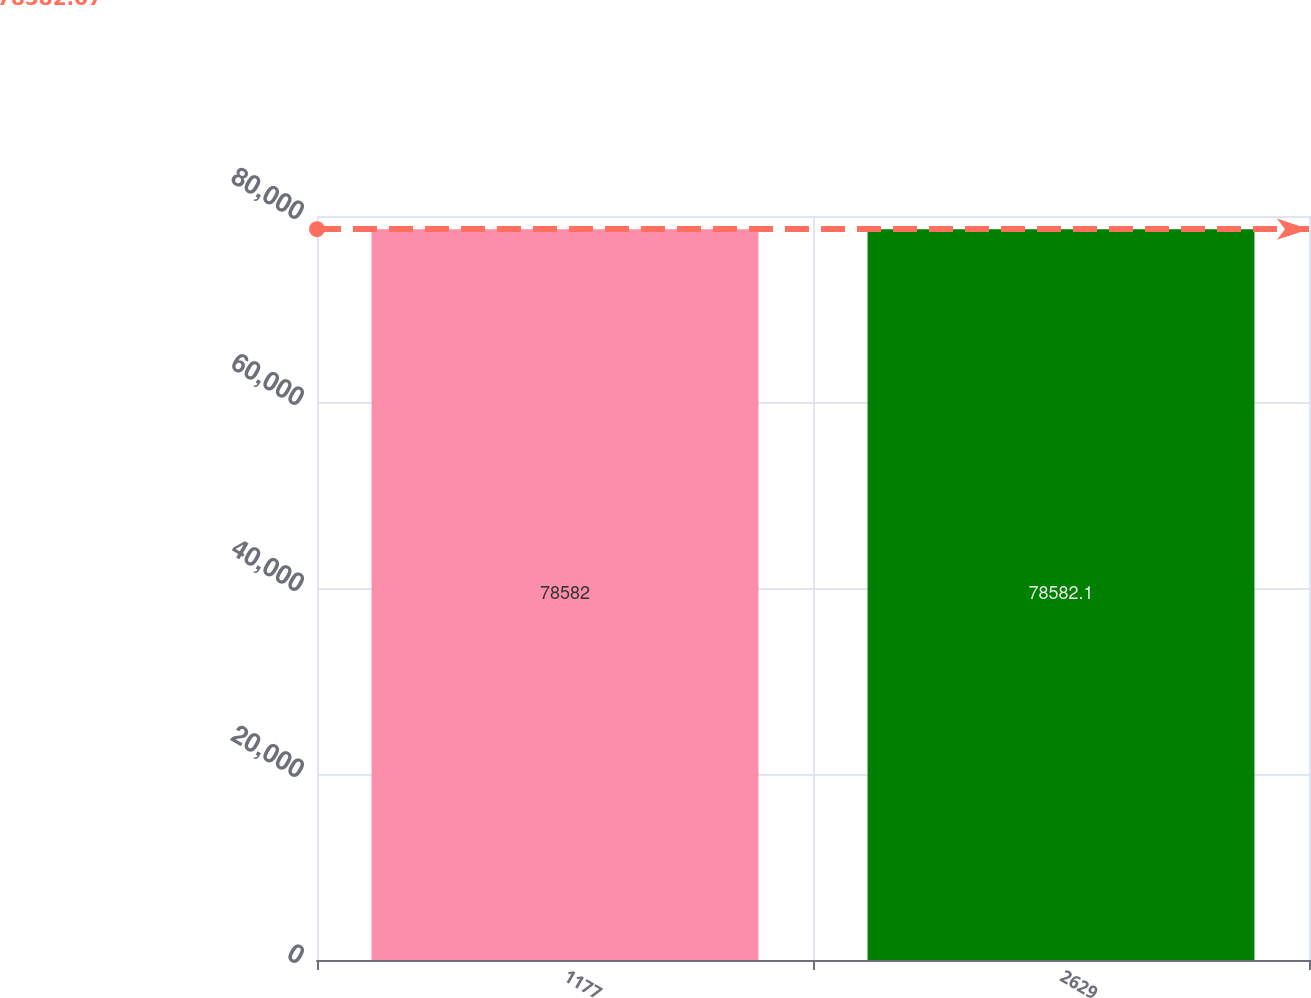<chart> <loc_0><loc_0><loc_500><loc_500><bar_chart><fcel>1177<fcel>2629<nl><fcel>78582<fcel>78582.1<nl></chart> 